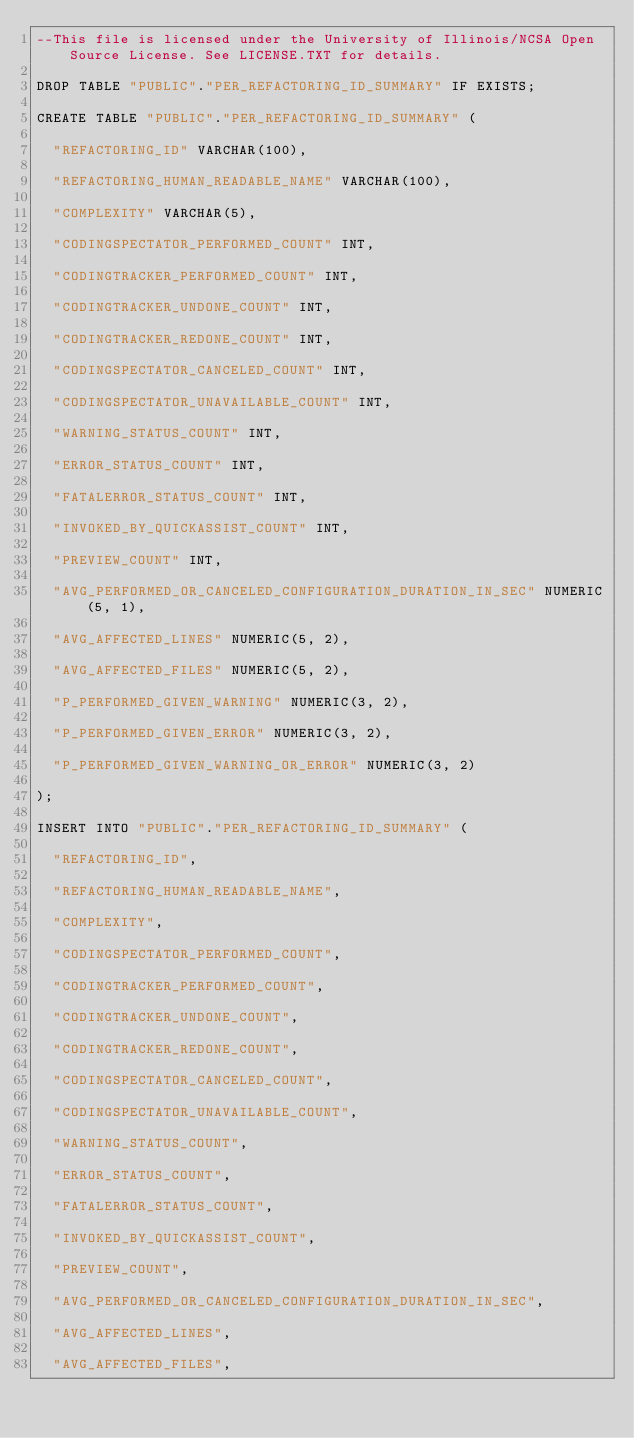<code> <loc_0><loc_0><loc_500><loc_500><_SQL_>--This file is licensed under the University of Illinois/NCSA Open Source License. See LICENSE.TXT for details.

DROP TABLE "PUBLIC"."PER_REFACTORING_ID_SUMMARY" IF EXISTS;

CREATE TABLE "PUBLIC"."PER_REFACTORING_ID_SUMMARY" (

  "REFACTORING_ID" VARCHAR(100),

  "REFACTORING_HUMAN_READABLE_NAME" VARCHAR(100),

  "COMPLEXITY" VARCHAR(5),

  "CODINGSPECTATOR_PERFORMED_COUNT" INT,

  "CODINGTRACKER_PERFORMED_COUNT" INT,

  "CODINGTRACKER_UNDONE_COUNT" INT,

  "CODINGTRACKER_REDONE_COUNT" INT,

  "CODINGSPECTATOR_CANCELED_COUNT" INT,

  "CODINGSPECTATOR_UNAVAILABLE_COUNT" INT,

  "WARNING_STATUS_COUNT" INT,

  "ERROR_STATUS_COUNT" INT,

  "FATALERROR_STATUS_COUNT" INT,

  "INVOKED_BY_QUICKASSIST_COUNT" INT,

  "PREVIEW_COUNT" INT,

  "AVG_PERFORMED_OR_CANCELED_CONFIGURATION_DURATION_IN_SEC" NUMERIC(5, 1),

  "AVG_AFFECTED_LINES" NUMERIC(5, 2),

  "AVG_AFFECTED_FILES" NUMERIC(5, 2),

  "P_PERFORMED_GIVEN_WARNING" NUMERIC(3, 2),

  "P_PERFORMED_GIVEN_ERROR" NUMERIC(3, 2),

  "P_PERFORMED_GIVEN_WARNING_OR_ERROR" NUMERIC(3, 2)

);

INSERT INTO "PUBLIC"."PER_REFACTORING_ID_SUMMARY" (

  "REFACTORING_ID",

  "REFACTORING_HUMAN_READABLE_NAME",

  "COMPLEXITY",

  "CODINGSPECTATOR_PERFORMED_COUNT",

  "CODINGTRACKER_PERFORMED_COUNT",

  "CODINGTRACKER_UNDONE_COUNT",

  "CODINGTRACKER_REDONE_COUNT",

  "CODINGSPECTATOR_CANCELED_COUNT",

  "CODINGSPECTATOR_UNAVAILABLE_COUNT",

  "WARNING_STATUS_COUNT",

  "ERROR_STATUS_COUNT",

  "FATALERROR_STATUS_COUNT",

  "INVOKED_BY_QUICKASSIST_COUNT",

  "PREVIEW_COUNT",

  "AVG_PERFORMED_OR_CANCELED_CONFIGURATION_DURATION_IN_SEC",

  "AVG_AFFECTED_LINES",

  "AVG_AFFECTED_FILES",
</code> 